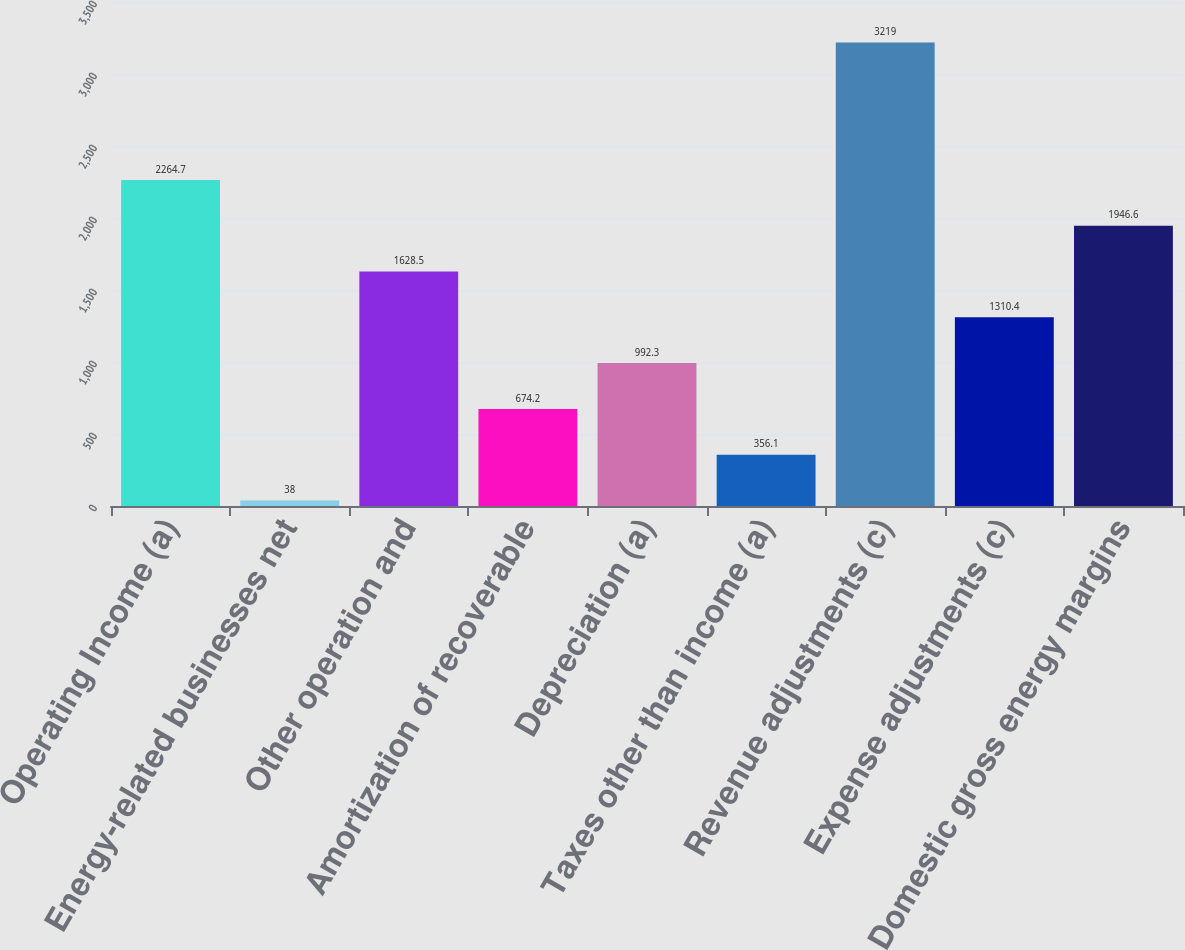Convert chart. <chart><loc_0><loc_0><loc_500><loc_500><bar_chart><fcel>Operating Income (a)<fcel>Energy-related businesses net<fcel>Other operation and<fcel>Amortization of recoverable<fcel>Depreciation (a)<fcel>Taxes other than income (a)<fcel>Revenue adjustments (c)<fcel>Expense adjustments (c)<fcel>Domestic gross energy margins<nl><fcel>2264.7<fcel>38<fcel>1628.5<fcel>674.2<fcel>992.3<fcel>356.1<fcel>3219<fcel>1310.4<fcel>1946.6<nl></chart> 